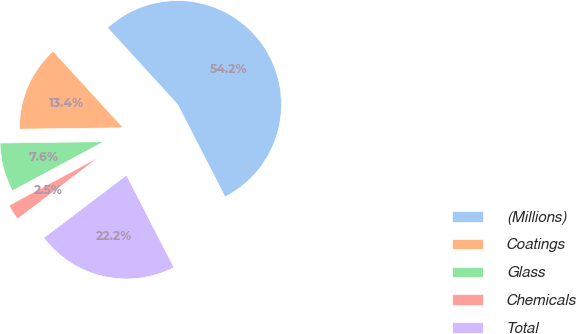Convert chart. <chart><loc_0><loc_0><loc_500><loc_500><pie_chart><fcel>(Millions)<fcel>Coatings<fcel>Glass<fcel>Chemicals<fcel>Total<nl><fcel>54.24%<fcel>13.42%<fcel>7.64%<fcel>2.47%<fcel>22.23%<nl></chart> 